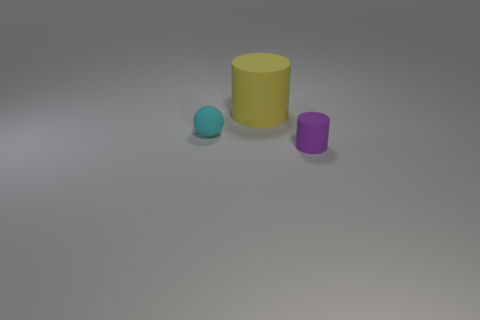Add 3 tiny purple rubber cylinders. How many objects exist? 6 Subtract all cylinders. How many objects are left? 1 Subtract 2 cylinders. How many cylinders are left? 0 Add 3 big yellow objects. How many big yellow objects exist? 4 Subtract 0 gray balls. How many objects are left? 3 Subtract all small blue cubes. Subtract all matte cylinders. How many objects are left? 1 Add 3 big yellow rubber cylinders. How many big yellow rubber cylinders are left? 4 